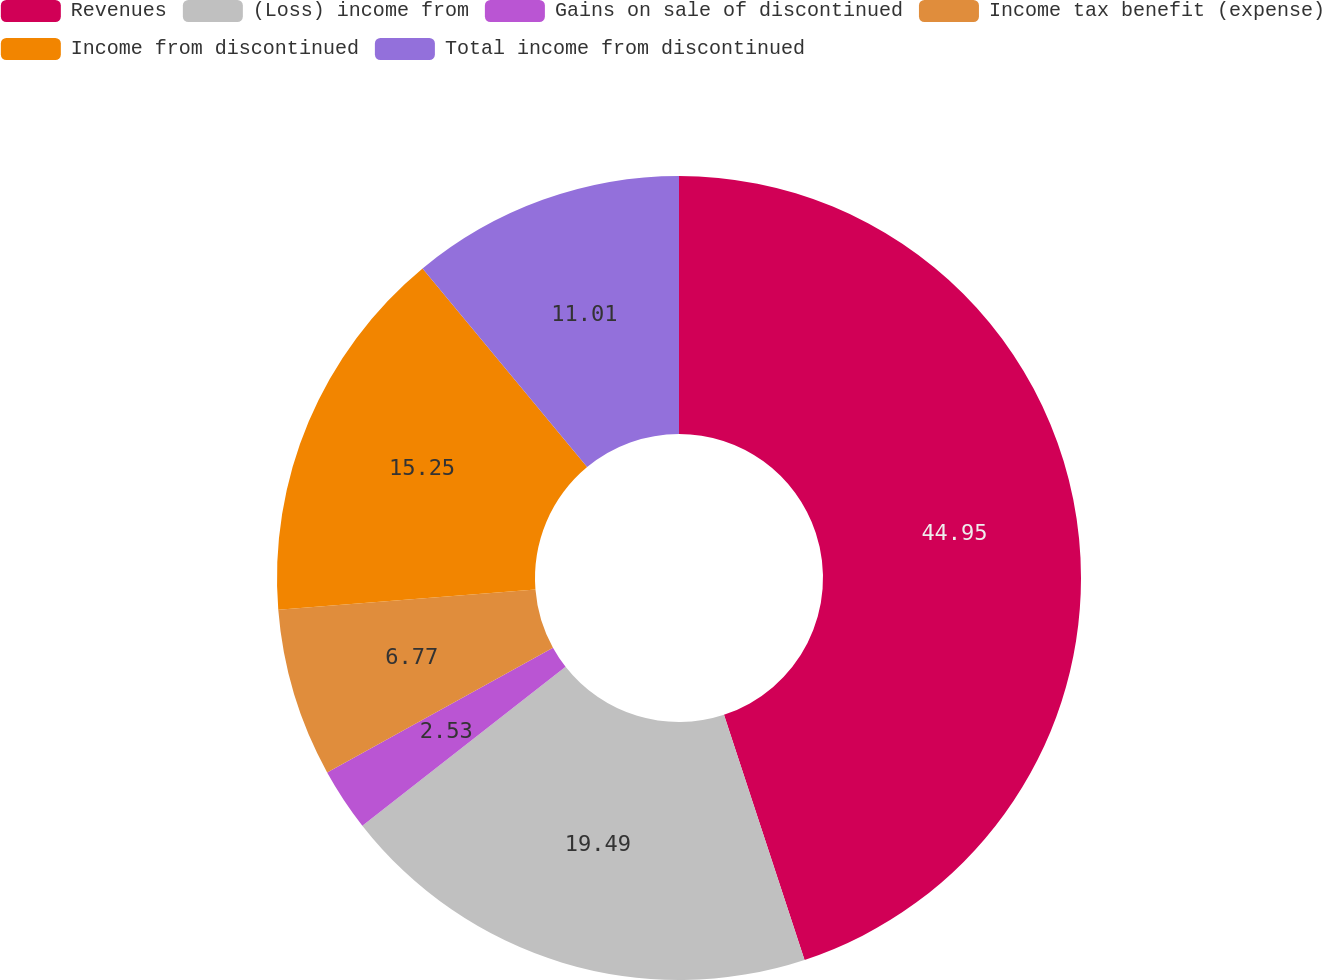<chart> <loc_0><loc_0><loc_500><loc_500><pie_chart><fcel>Revenues<fcel>(Loss) income from<fcel>Gains on sale of discontinued<fcel>Income tax benefit (expense)<fcel>Income from discontinued<fcel>Total income from discontinued<nl><fcel>44.94%<fcel>19.49%<fcel>2.53%<fcel>6.77%<fcel>15.25%<fcel>11.01%<nl></chart> 